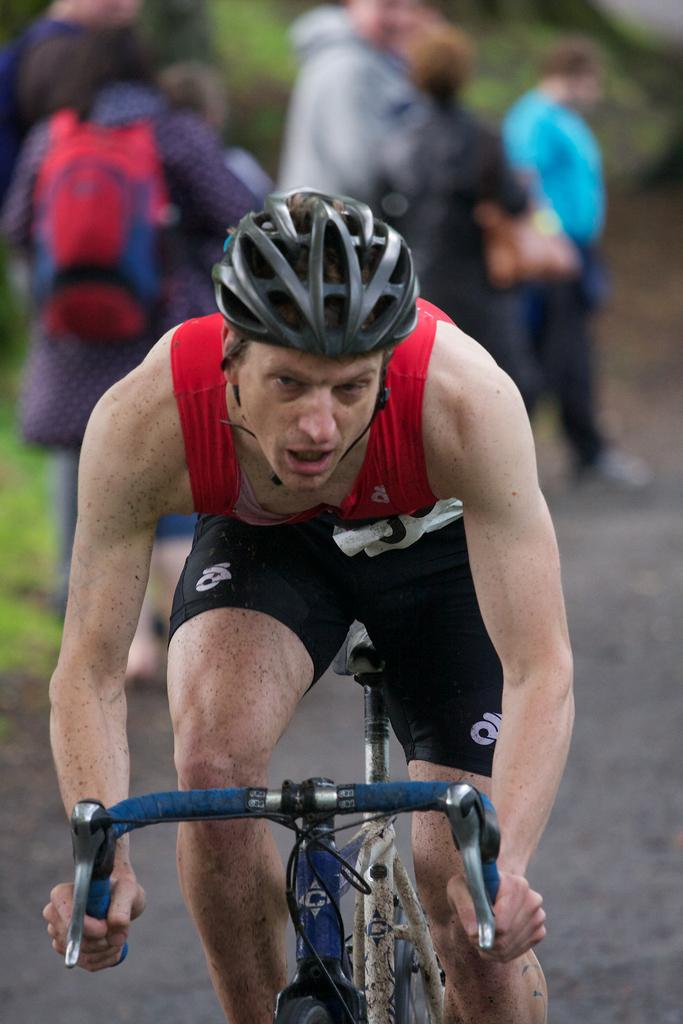What is the main subject of the image? There is a person riding a bicycle in the image. Are there any other people present in the image? Yes, there is a group of people standing at the back in the image. What can be seen in the background of the image? There are trees visible in the image. What is at the bottom of the image? There is a road at the bottom of the image. What type of clock is hanging on the tree in the image? There is no clock present in the image; it only features a person riding a bicycle, a group of people, trees, and a road. 